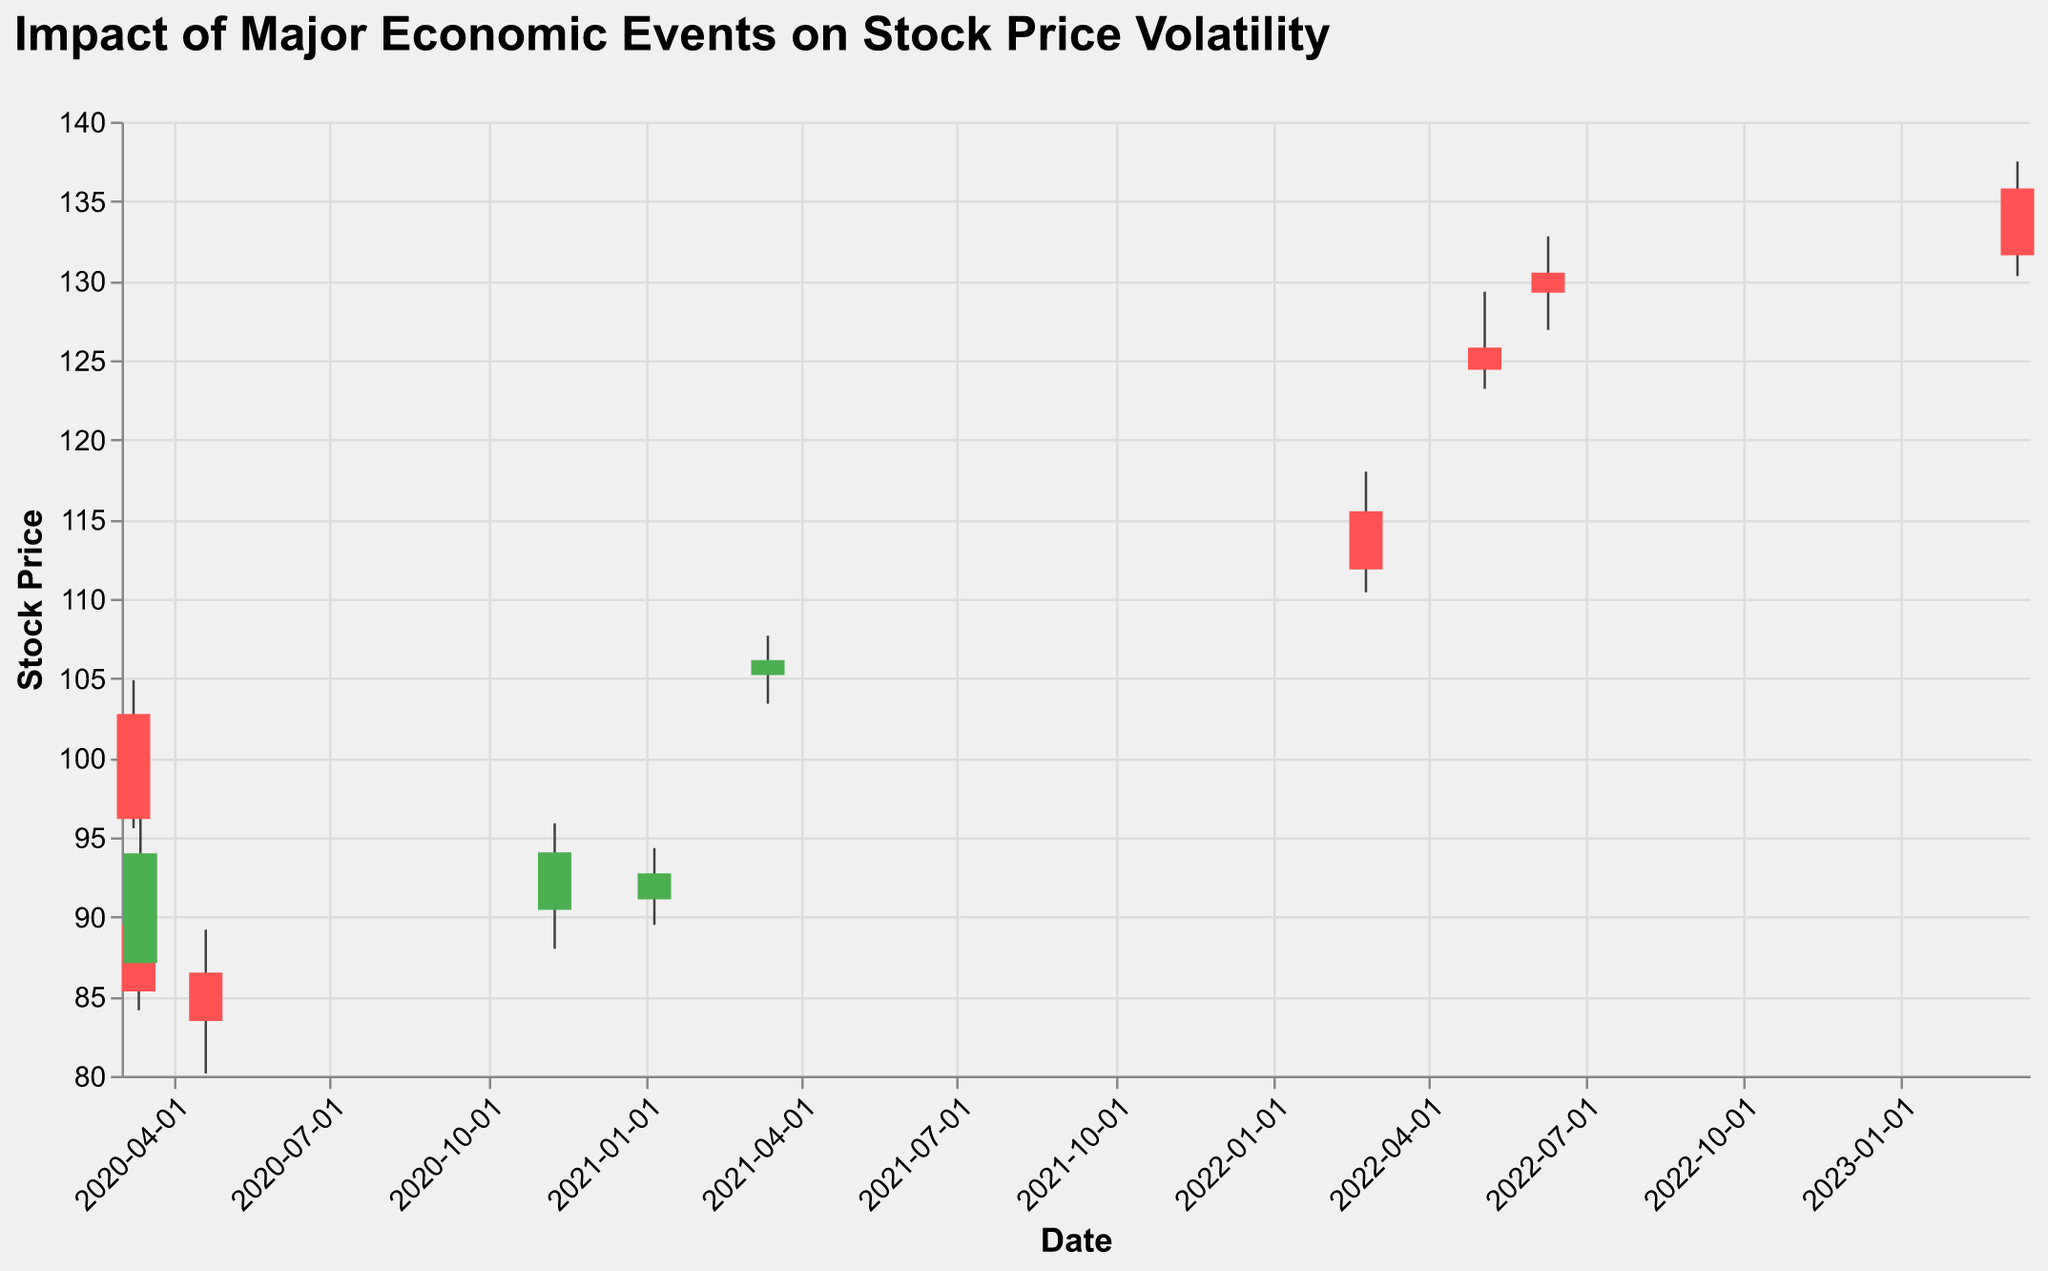What's the date of the first data point in the figure? The first data point corresponds to the earliest date present at the far left of the x-axis.
Answer: March 9, 2020 What event caused the highest stock price drop within a single day? By checking the significant drops between opening and closing prices, the "Stock Market Crash" on March 12, 2020, shows the steepest decline when comparing the open and close values.
Answer: Stock Market Crash How much did the stock price change between the open and close on March 13, 2020? Find the open price (87.10) and the close price (94.00) for March 13, 2020, and calculate the difference: 94.00 - 87.10.
Answer: 6.90 Which economic event had a positive impact on the stock price, causing it to close higher than the open price? Look for events where the closing price is higher than the opening price. The "Federal Reserve Interest Rate Cut" on March 13, 2020, is an example.
Answer: Federal Reserve Interest Rate Cut What was the stock price high on the day the COVID-19 pandemic was declared? Look at the high value for the data point corresponding to March 9, 2020.
Answer: 104.88 Which event had the highest trading volume? Compare the volume values across all events; the "Stock Market Crash" on March 12, 2020, had the highest volume.
Answer: Stock Market Crash How did the stock price react to the initial COVID-19 vaccine announcement on November 9, 2020? Look at the data for November 9, 2020, where the open price is 90.44 and the close price is 94.05, indicating a positive reaction (price increase).
Answer: Increased Compare the stock price high before and after the "U.S. Inflation Rate Hits 8.6%" event. Check the high price on June 10, 2022 (132.78), and compare it with the high price of the next event, March 10, 2023 (137.50).
Answer: Higher after What was the overall trend in stock prices from March 2020 to March 2023? Assess the general direction of price changes, noting the initial drop in March 2020 and a gradual increase until March 2023.
Answer: Upward What was the stock price low on the day of the Silicon Valley Bank collapse in 2023? Identify the low value for the data point on March 10, 2023.
Answer: 130.30 